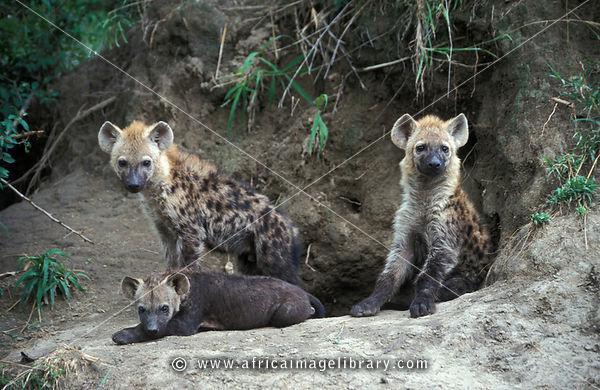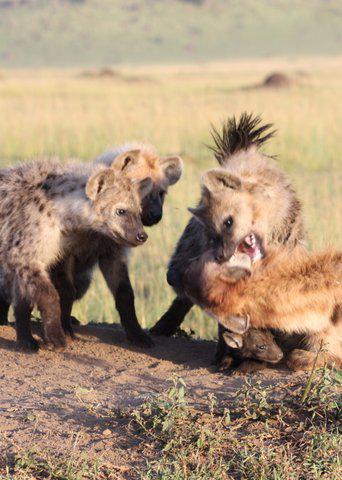The first image is the image on the left, the second image is the image on the right. Evaluate the accuracy of this statement regarding the images: "the right side image has only two animals". Is it true? Answer yes or no. No. The first image is the image on the left, the second image is the image on the right. Assess this claim about the two images: "there are a minimum of 7 hyenas present.". Correct or not? Answer yes or no. Yes. 